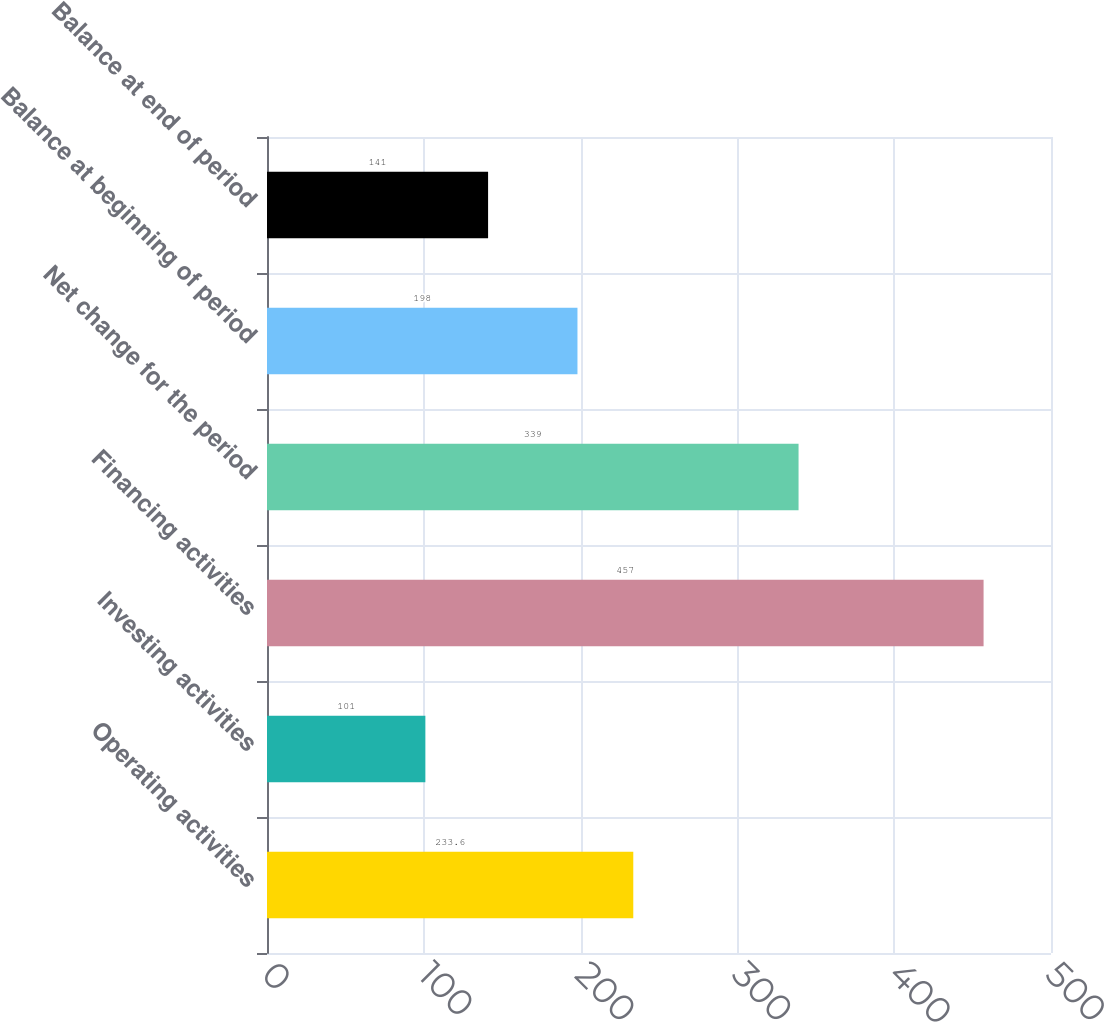Convert chart. <chart><loc_0><loc_0><loc_500><loc_500><bar_chart><fcel>Operating activities<fcel>Investing activities<fcel>Financing activities<fcel>Net change for the period<fcel>Balance at beginning of period<fcel>Balance at end of period<nl><fcel>233.6<fcel>101<fcel>457<fcel>339<fcel>198<fcel>141<nl></chart> 